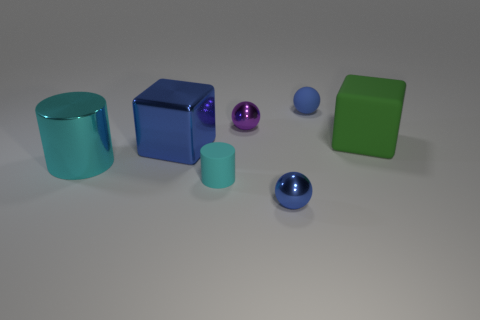Add 1 small blue shiny objects. How many objects exist? 8 Subtract all spheres. How many objects are left? 4 Add 2 brown matte objects. How many brown matte objects exist? 2 Subtract 0 brown blocks. How many objects are left? 7 Subtract all large cyan matte cylinders. Subtract all small blue shiny spheres. How many objects are left? 6 Add 3 small objects. How many small objects are left? 7 